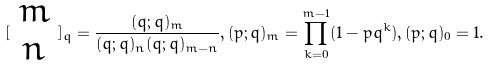<formula> <loc_0><loc_0><loc_500><loc_500>[ \begin{array} { c } m \\ n \end{array} ] _ { q } = \frac { ( q ; q ) _ { m } } { ( q ; q ) _ { n } ( q ; q ) _ { m - n } } , ( p ; q ) _ { m } = \prod _ { k = 0 } ^ { m - 1 } ( 1 - p q ^ { k } ) , ( p ; q ) _ { 0 } = 1 .</formula> 